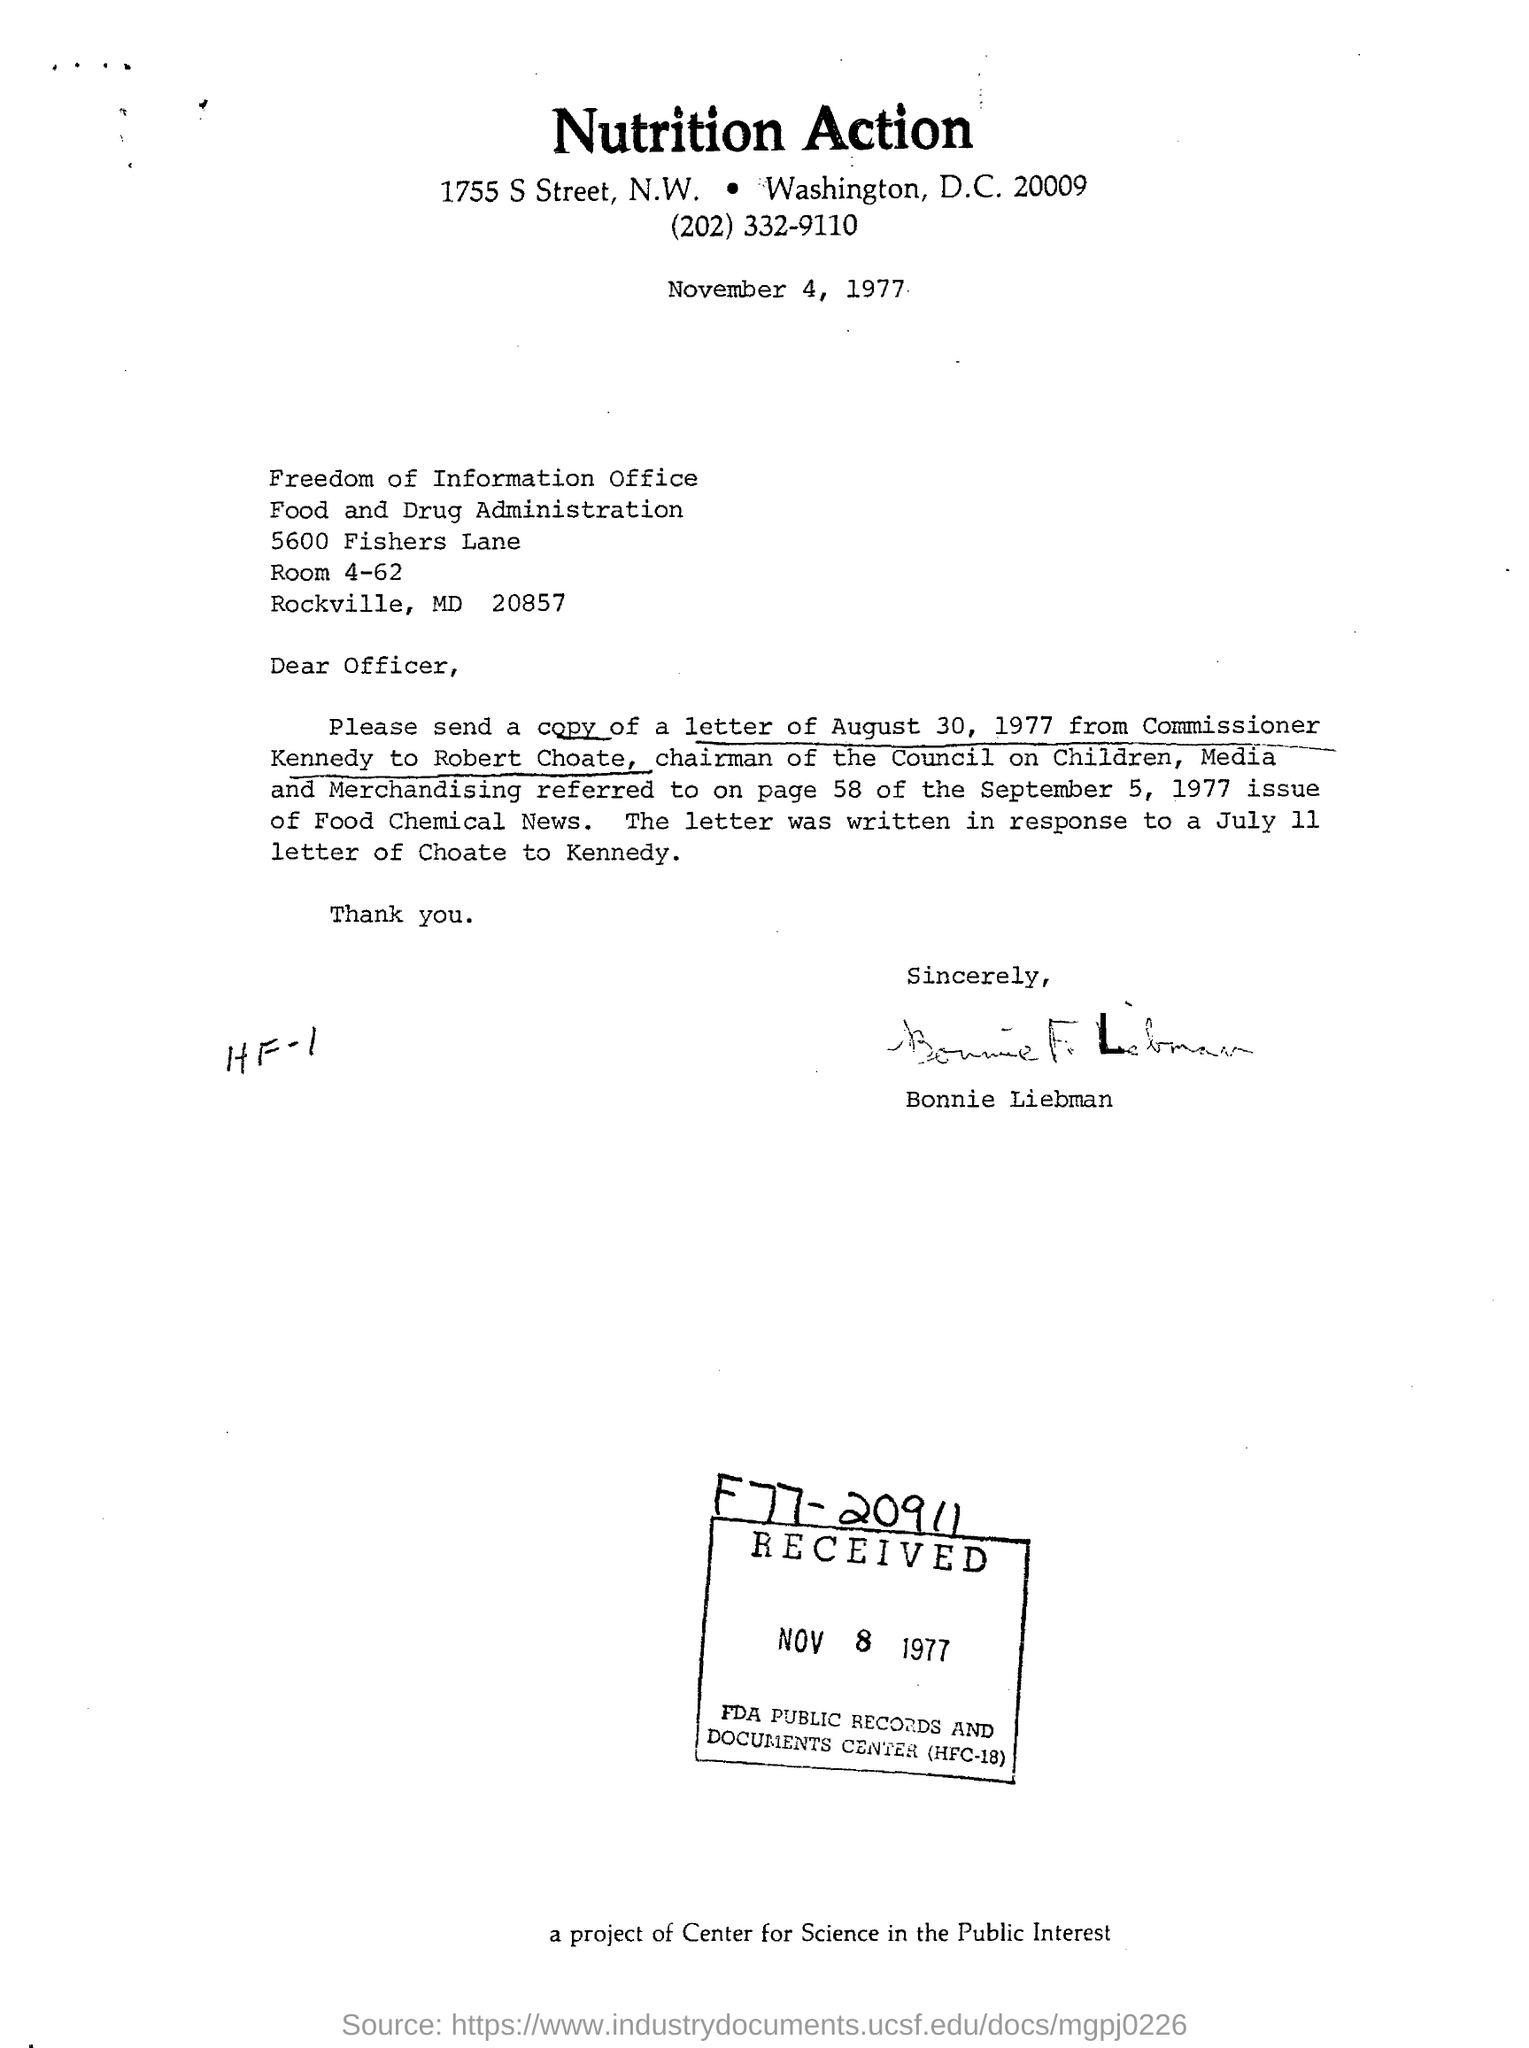Who is the chairman of the council on children, media and merchandising?
Make the answer very short. Robert Choate. What is the name of the office mentioned in the letter?
Provide a succinct answer. Freedom of information office. Who has signed the letter?
Provide a short and direct response. Bonnie Liebman. What is the heading of the document?
Offer a very short reply. Nutrition action. 